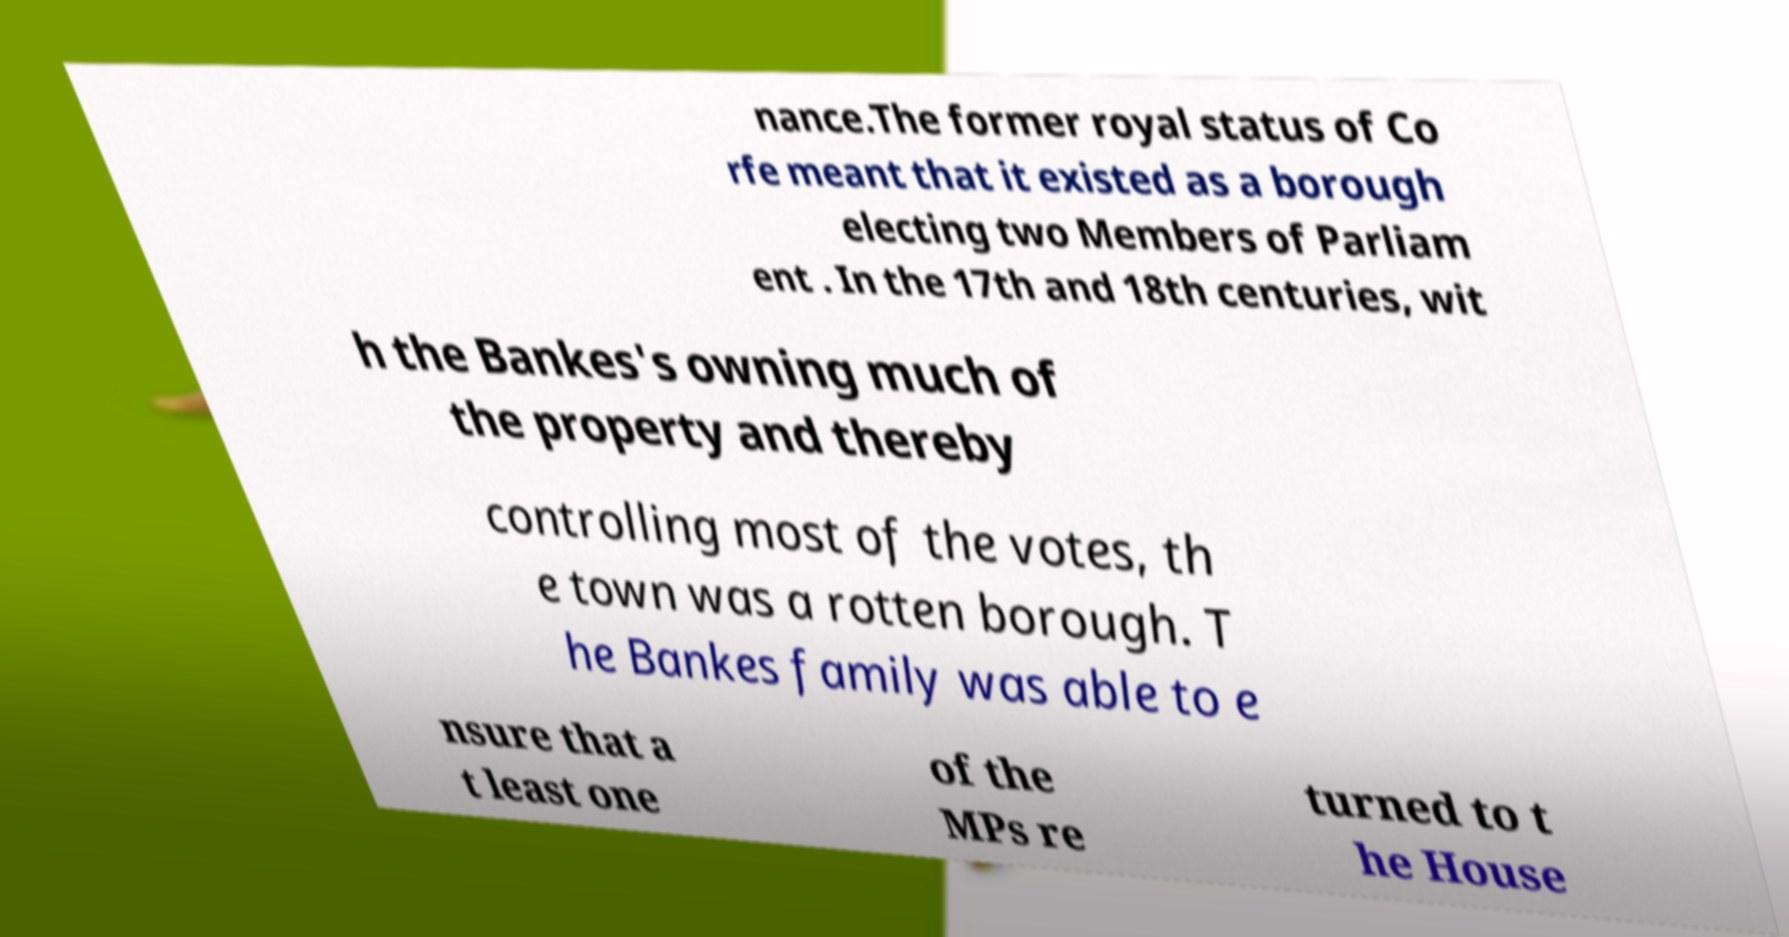For documentation purposes, I need the text within this image transcribed. Could you provide that? nance.The former royal status of Co rfe meant that it existed as a borough electing two Members of Parliam ent . In the 17th and 18th centuries, wit h the Bankes's owning much of the property and thereby controlling most of the votes, th e town was a rotten borough. T he Bankes family was able to e nsure that a t least one of the MPs re turned to t he House 